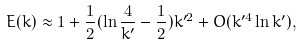Convert formula to latex. <formula><loc_0><loc_0><loc_500><loc_500>E ( k ) \approx 1 + \frac { 1 } { 2 } ( \ln \frac { 4 } { k ^ { \prime } } - \frac { 1 } { 2 } ) k ^ { \prime 2 } + O ( k ^ { \prime 4 } \ln k ^ { \prime } ) ,</formula> 